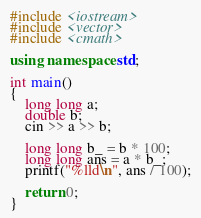<code> <loc_0><loc_0><loc_500><loc_500><_C++_>#include <iostream>
#include <vector>
#include <cmath>

using namespace std;

int main()
{
	long long a;
	double b;
	cin >> a >> b;
	
	long long b_ = b * 100;
	long long ans = a * b_;
	printf("%lld\n", ans / 100);

	return 0;
}</code> 